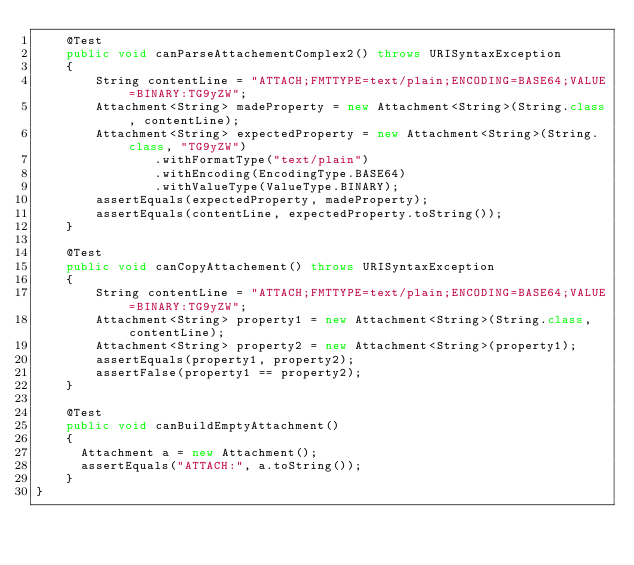<code> <loc_0><loc_0><loc_500><loc_500><_Java_>    @Test
    public void canParseAttachementComplex2() throws URISyntaxException
    {
        String contentLine = "ATTACH;FMTTYPE=text/plain;ENCODING=BASE64;VALUE=BINARY:TG9yZW";
        Attachment<String> madeProperty = new Attachment<String>(String.class, contentLine);
        Attachment<String> expectedProperty = new Attachment<String>(String.class, "TG9yZW")
                .withFormatType("text/plain")
                .withEncoding(EncodingType.BASE64)
                .withValueType(ValueType.BINARY);
        assertEquals(expectedProperty, madeProperty);
        assertEquals(contentLine, expectedProperty.toString());
    }
    
    @Test
    public void canCopyAttachement() throws URISyntaxException
    {
        String contentLine = "ATTACH;FMTTYPE=text/plain;ENCODING=BASE64;VALUE=BINARY:TG9yZW";
        Attachment<String> property1 = new Attachment<String>(String.class, contentLine);
        Attachment<String> property2 = new Attachment<String>(property1);
        assertEquals(property1, property2);
        assertFalse(property1 == property2);
    }
    
    @Test
    public void canBuildEmptyAttachment()
    {
    	Attachment a = new Attachment();
    	assertEquals("ATTACH:", a.toString());
    }
}
</code> 